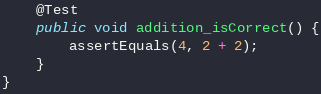Convert code to text. <code><loc_0><loc_0><loc_500><loc_500><_Java_>    @Test
    public void addition_isCorrect() {
        assertEquals(4, 2 + 2);
    }
}</code> 